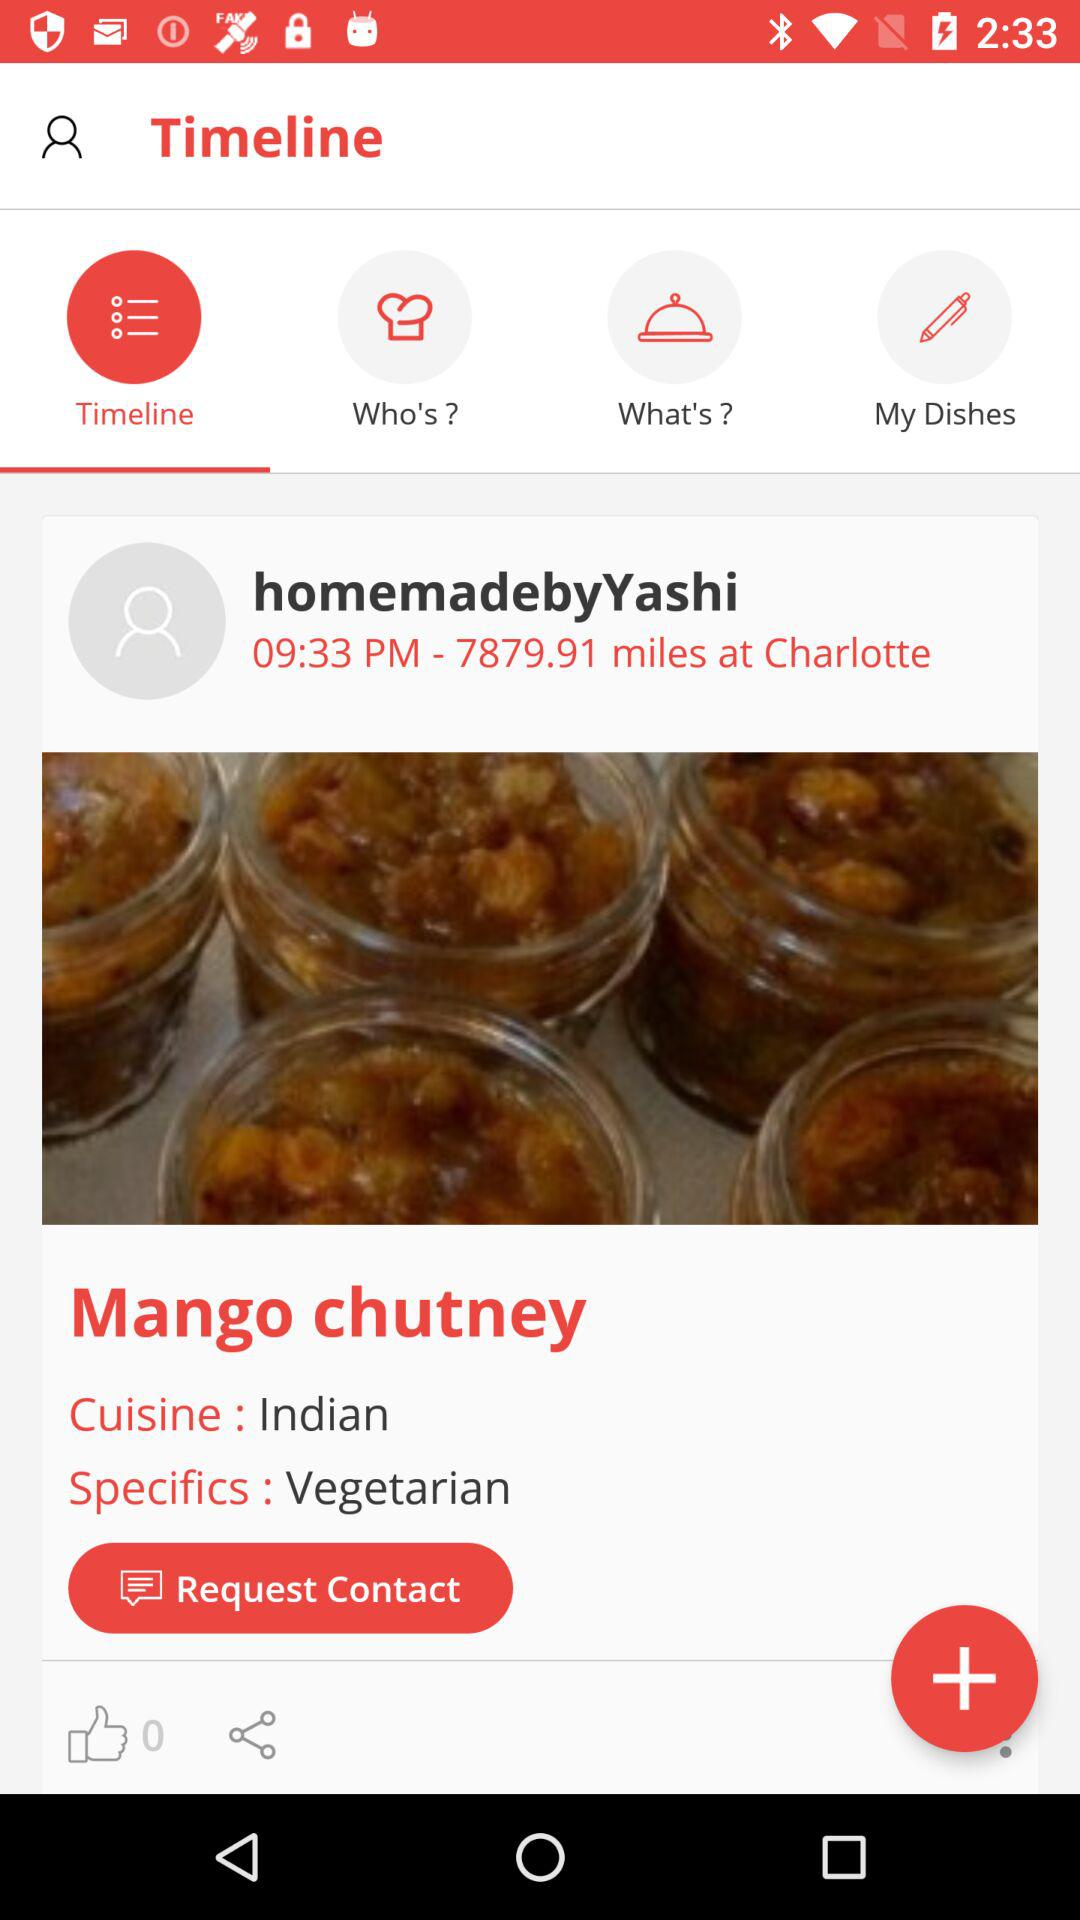What is the distance? The distance is 7879.91 miles. 